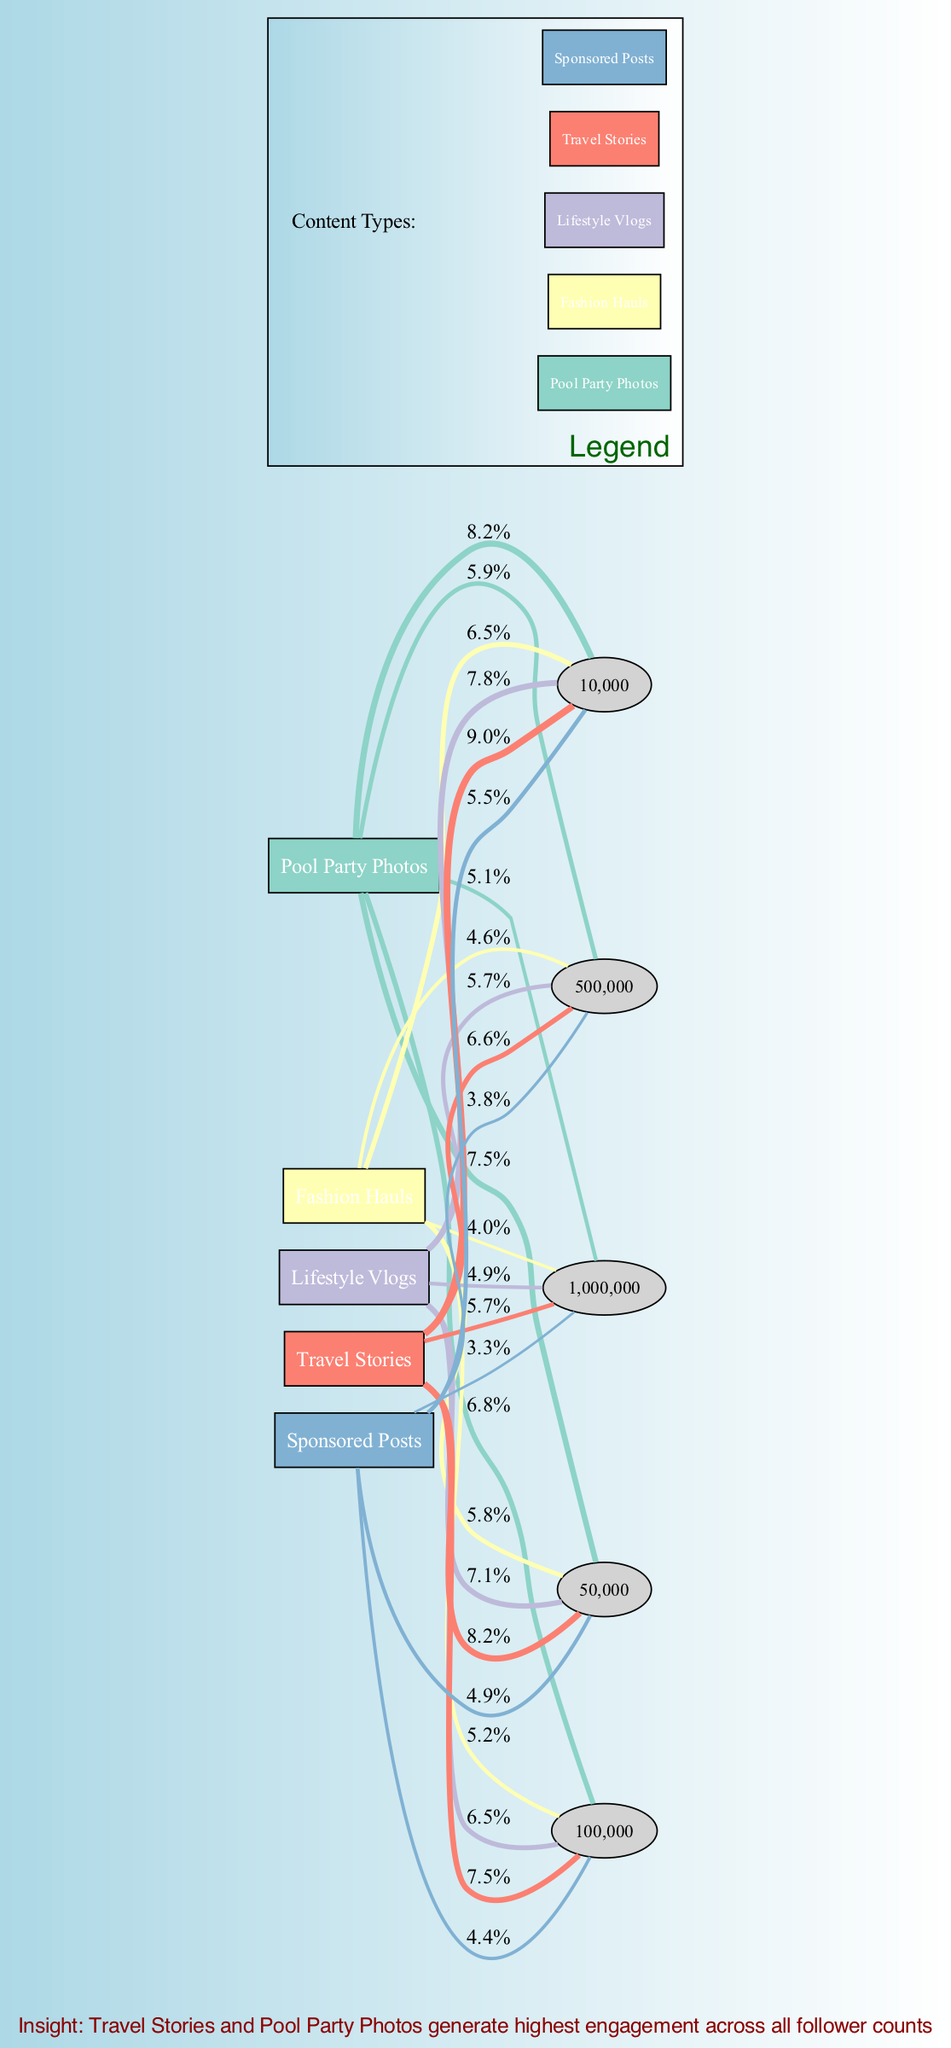what is the engagement rate for Pool Party Photos at 100,000 followers? In the diagram, we can find the values associated with "Pool Party Photos" and look specifically at the data point for 100,000 followers. The engagement rate corresponding to that follower count is 6.8%.
Answer: 6.8% which content type has the highest engagement rate at 500,000 followers? To determine this, we compare the engagement rates for all content types at 500,000 followers. Checking the values, "Travel Stories" has an engagement rate of 6.6%, which is higher than others like "Pool Party Photos" at 5.9%, "Fashion Hauls" at 4.6%, "Lifestyle Vlogs" at 5.7%, and "Sponsored Posts" at 3.8%.
Answer: Travel Stories what is the lowest engagement rate across all content types at 1,000,000 followers? Looking at the engagement rates for each content type at 1,000,000 followers, we see "Sponsored Posts" has the lowest engagement rate of 3.3%.
Answer: 3.3% how many content types are included in the diagram? The diagram lists multiple types of content, which can be counted by identifying each unique rectangle representing a content type. There are five distinct content types shown.
Answer: 5 what is the trend in engagement rates for Sponsored Posts as follower count increases? Observing the engagement rates for "Sponsored Posts," we see they decrease as follower count increases. The respective rates are 5.5% at 10,000 followers, down to 3.3% at 1,000,000 followers, indicating a downward trend.
Answer: Decreasing which two content types consistently have the highest engagement rates across all follower counts? To answer this, I compare the engagement rates for all follower counts across the content types shown. It can be seen that "Travel Stories" and "Pool Party Photos" consistently maintain higher engagement rates compared to others throughout the follower counts presented.
Answer: Travel Stories, Pool Party Photos what is the engagement rate for Lifestyle Vlogs at 50,000 followers? By locating "Lifestyle Vlogs" and finding its engagement rate at 50,000 followers, we see that the engagement rate is 7.1%.
Answer: 7.1% at 10,000 followers, which content type has the highest engagement rate? At 10,000 followers, the engagement rates for each content type need to be compared: "Travel Stories" is 9.0%, "Pool Party Photos" is 8.2%, "Lifestyle Vlogs" is 7.8%, "Fashion Hauls" is 6.5%, and "Sponsored Posts" is 5.5%. "Travel Stories" has the highest rate.
Answer: Travel Stories 